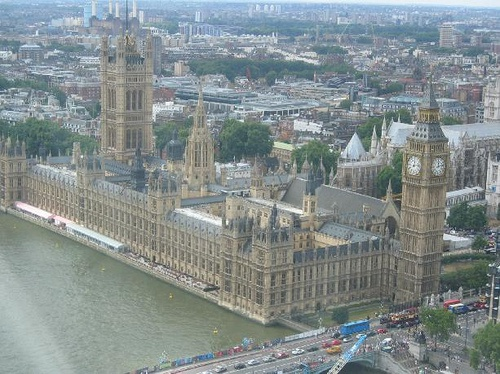Describe the objects in this image and their specific colors. I can see bus in lightblue, gray, and blue tones, car in lightblue, gray, and darkgray tones, clock in lightblue, darkgray, lightgray, and gray tones, clock in lightblue, darkgray, gray, and lightgray tones, and bus in lightblue, gray, darkblue, and white tones in this image. 